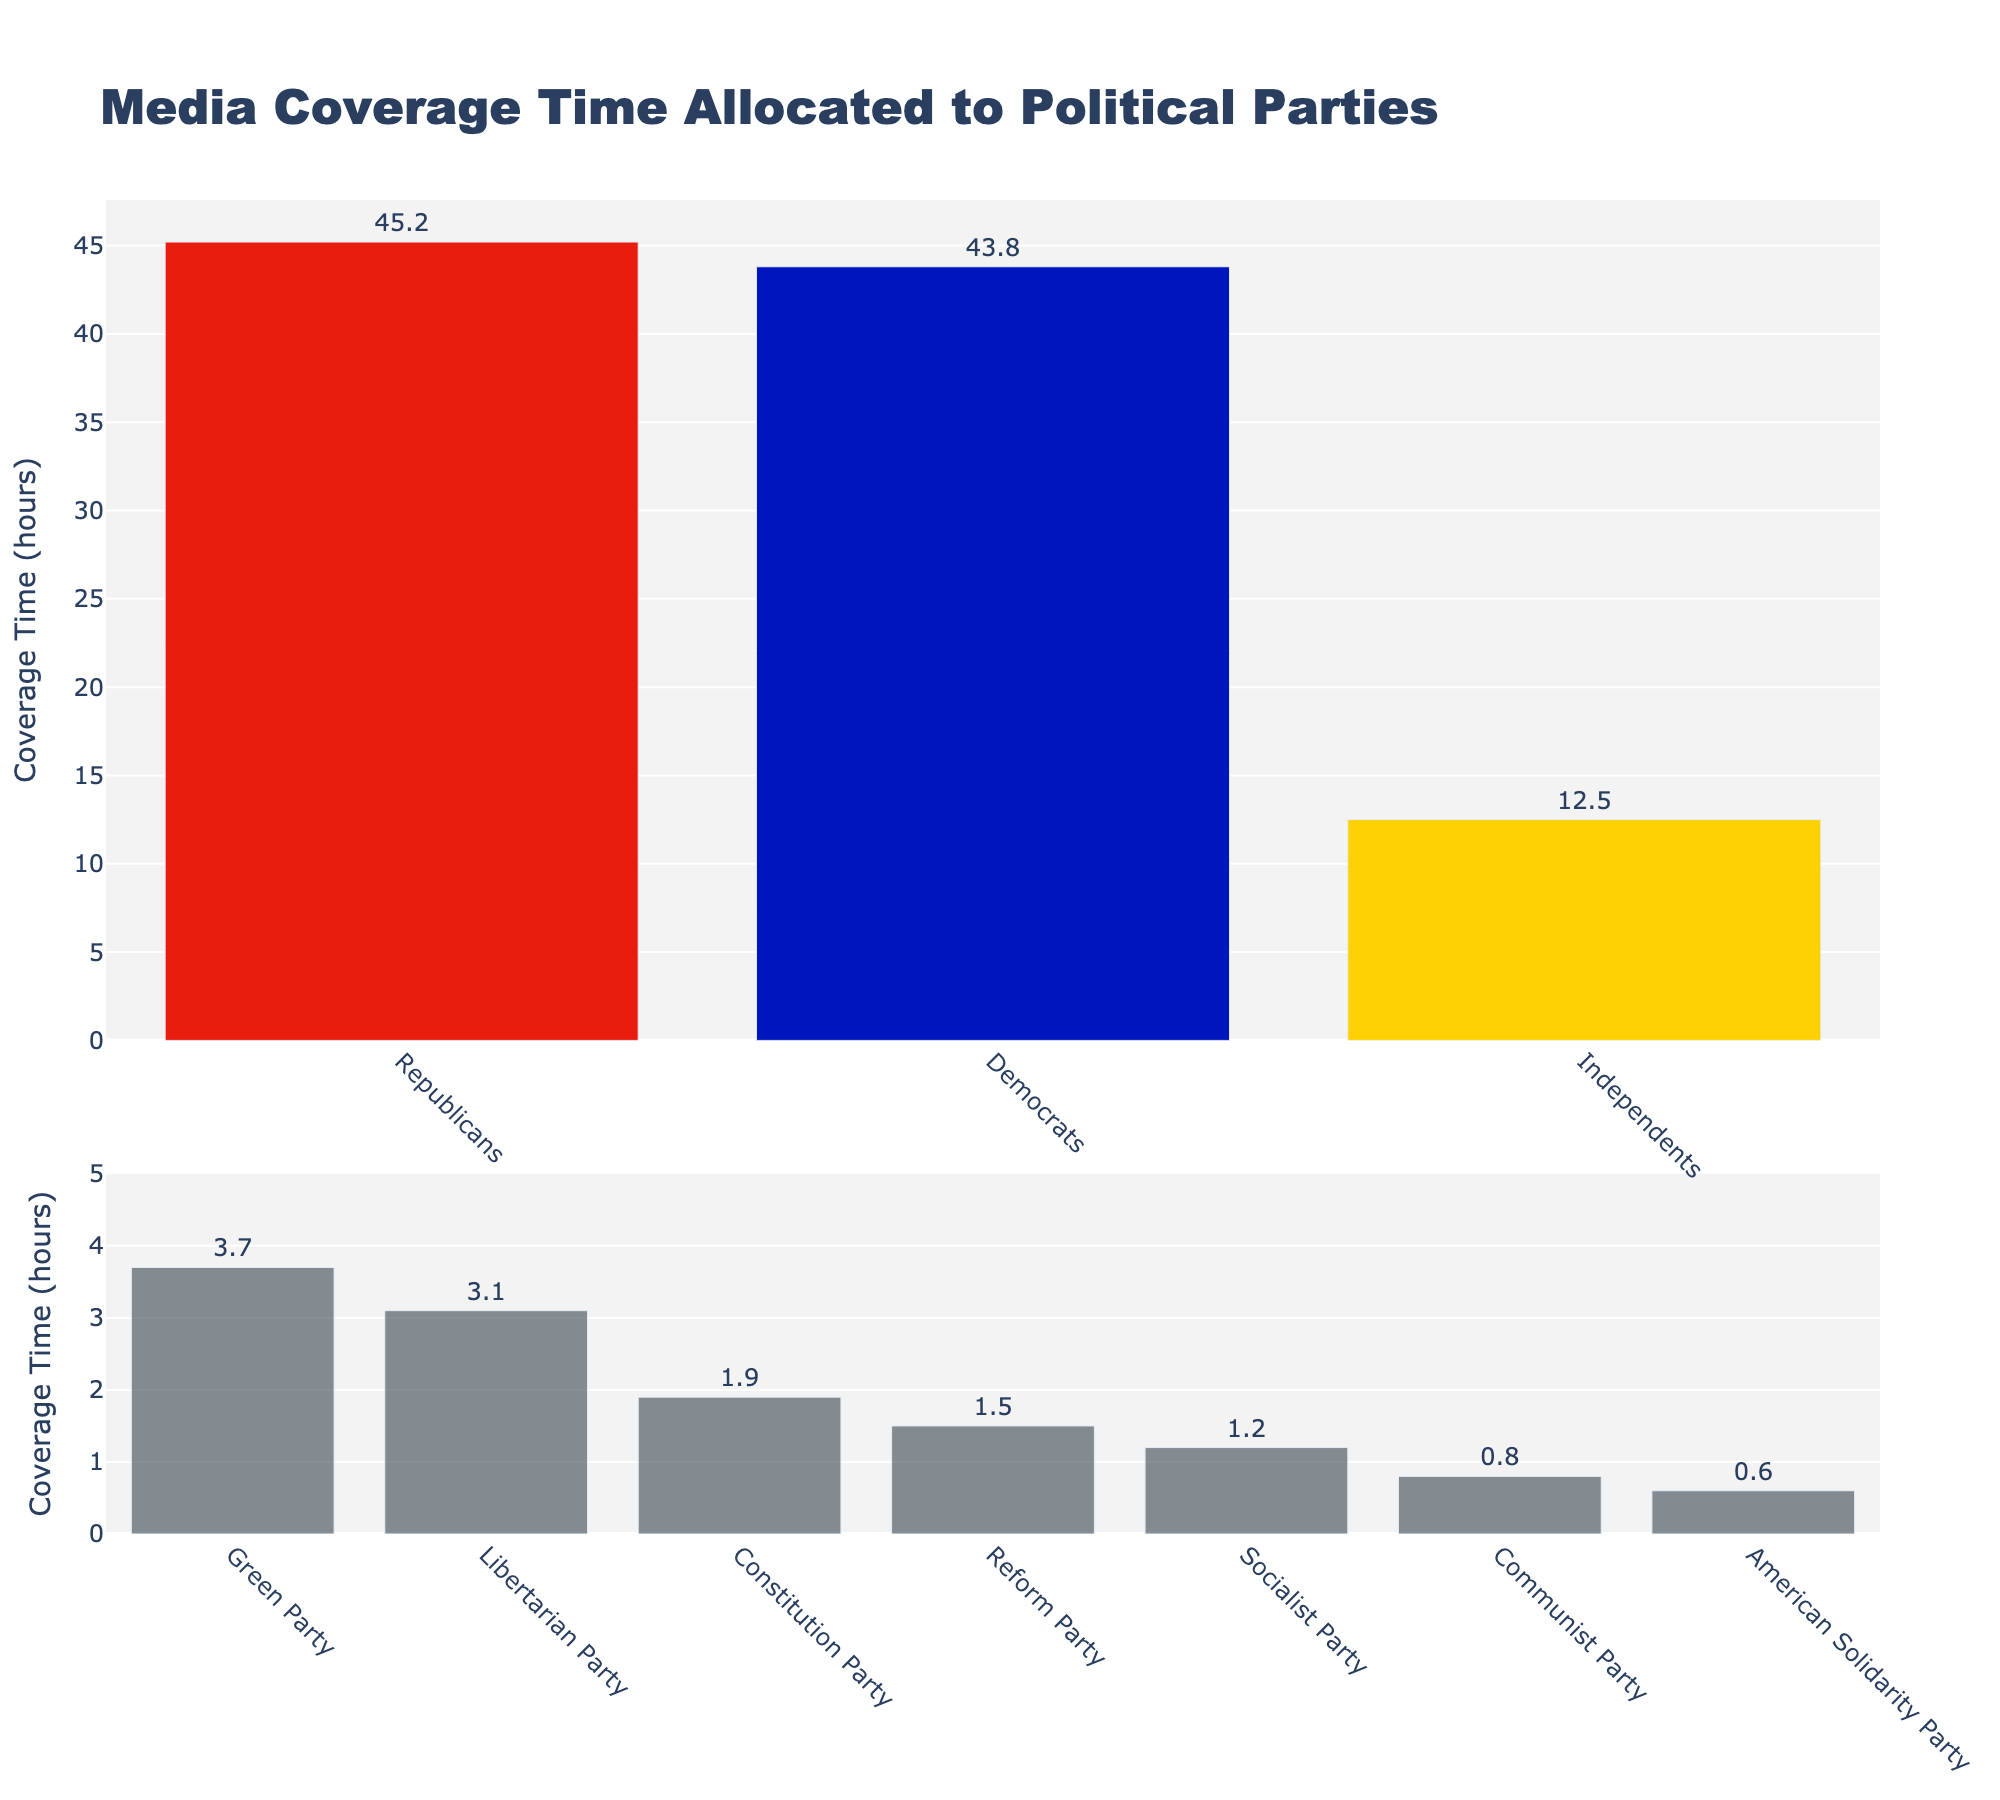Which party received the most media coverage? The bar representing the Republicans is the tallest in the first chart, indicating that they have the highest coverage time.
Answer: Republicans What is the total media coverage time for the Democrats and Republicans combined? The bar chart shows that the Republicans have 45.2 hours, and the Democrats have 43.8 hours. Summing these values gives 45.2 + 43.8 = 89.0 hours.
Answer: 89.0 hours Which minor party received the least media coverage? In the second chart for minor parties, the bar representing the American Solidarity Party is the shortest, indicating that they have the lowest coverage time.
Answer: American Solidarity Party How much more media coverage did the Republicans receive compared to the Independents? The Republicans have 45.2 hours, and the Independents have 12.5 hours. Subtracting these values gives 45.2 - 12.5 = 32.7 hours.
Answer: 32.7 hours Are there any parties that received an equal amount of media coverage? By observing the height of the bars, all bars are of different heights, meaning no two parties received an equal amount of media coverage.
Answer: No What's the average media coverage for the minor parties (those in the second chart)? The minor parties listed have coverage times of 3.7, 3.1, 1.9, 1.5, 1.2, 0.8, and 0.6. Adding these values gives 12.8. There are seven parties, so the average is 12.8 / 7 ≈ 1.83 hours.
Answer: 1.83 hours Which party has the second highest media coverage time? Based on the height of the bars in the first chart, the Democrats have the second tallest bar indicating that they have the second highest coverage time.
Answer: Democrats How many hours more coverage did the major parties (Republicans, Democrats, and Independents) receive over the minor parties combined? Sum of major parties' coverage: 45.2 + 43.8 + 12.5 = 101.5 hours. Sum of minor parties' coverage: 3.7 + 3.1 + 1.9 + 1.5 + 1.2 + 0.8 + 0.6 = 12.8 hours. Difference is 101.5 - 12.8 = 88.7 hours.
Answer: 88.7 hours What percentage of the total coverage time was allocated to the Green Party? The Green Party received 3.7 hours. The total media coverage is 45.2 + 43.8 + 12.5 + 3.7 + 3.1 + 1.9 + 1.5 + 1.2 + 0.8 + 0.6 = 114.3 hours. (3.7 / 114.3) * 100% ≈ 3.24%.
Answer: 3.24% 